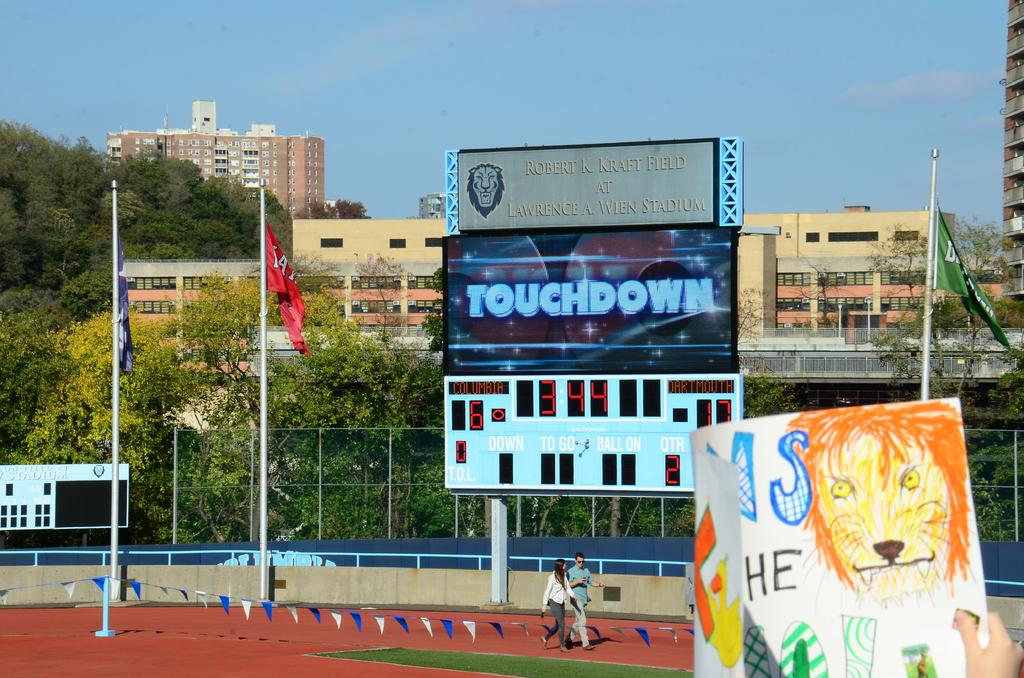<image>
Describe the image concisely. A sports field with a sign that says touchdown 